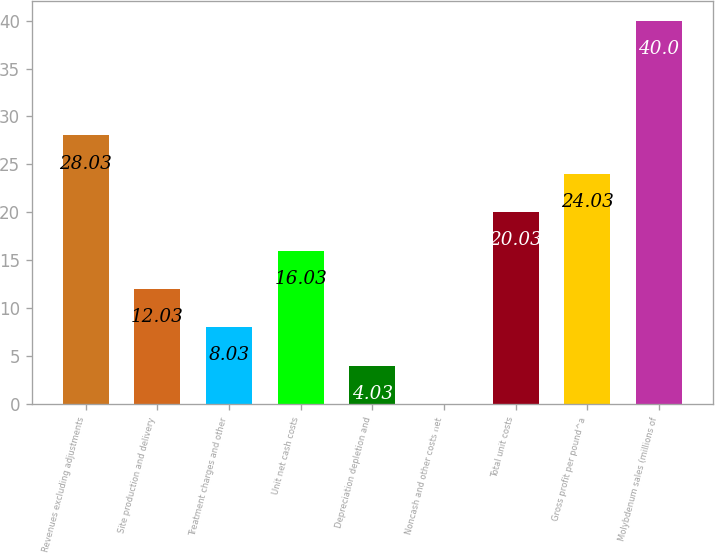Convert chart. <chart><loc_0><loc_0><loc_500><loc_500><bar_chart><fcel>Revenues excluding adjustments<fcel>Site production and delivery<fcel>Treatment charges and other<fcel>Unit net cash costs<fcel>Depreciation depletion and<fcel>Noncash and other costs net<fcel>Total unit costs<fcel>Gross profit per pound^a<fcel>Molybdenum sales (millions of<nl><fcel>28.03<fcel>12.03<fcel>8.03<fcel>16.03<fcel>4.03<fcel>0.03<fcel>20.03<fcel>24.03<fcel>40<nl></chart> 